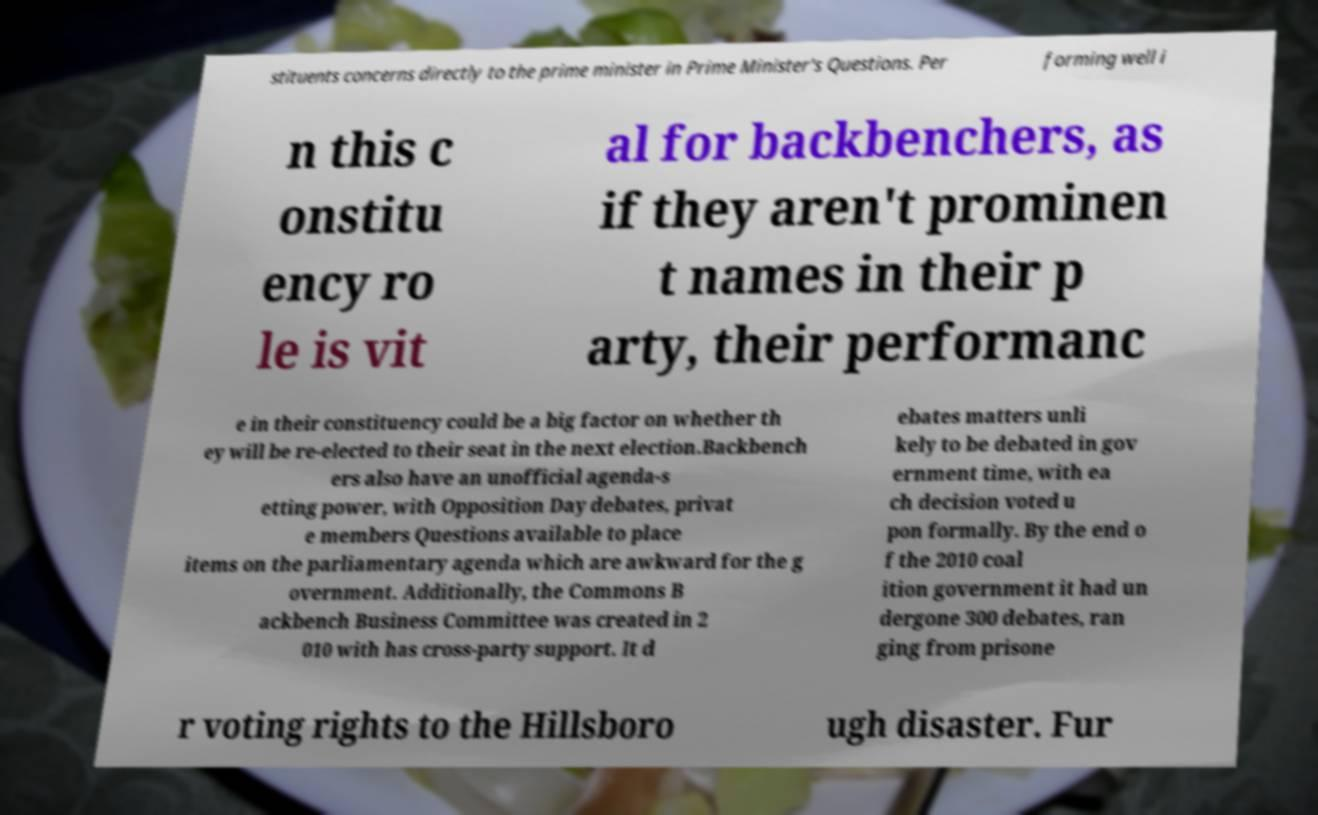Could you assist in decoding the text presented in this image and type it out clearly? stituents concerns directly to the prime minister in Prime Minister's Questions. Per forming well i n this c onstitu ency ro le is vit al for backbenchers, as if they aren't prominen t names in their p arty, their performanc e in their constituency could be a big factor on whether th ey will be re-elected to their seat in the next election.Backbench ers also have an unofficial agenda-s etting power, with Opposition Day debates, privat e members Questions available to place items on the parliamentary agenda which are awkward for the g overnment. Additionally, the Commons B ackbench Business Committee was created in 2 010 with has cross-party support. It d ebates matters unli kely to be debated in gov ernment time, with ea ch decision voted u pon formally. By the end o f the 2010 coal ition government it had un dergone 300 debates, ran ging from prisone r voting rights to the Hillsboro ugh disaster. Fur 